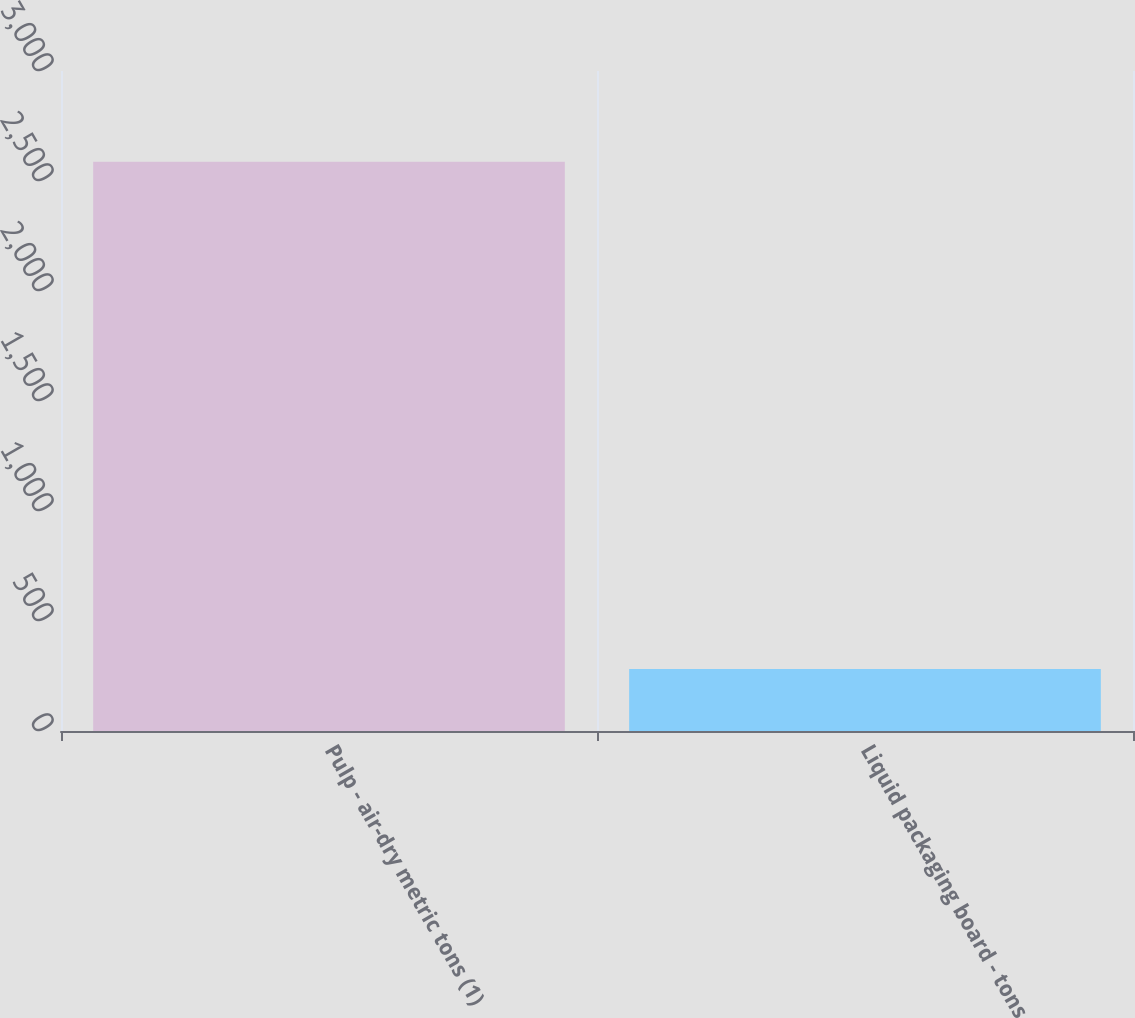Convert chart. <chart><loc_0><loc_0><loc_500><loc_500><bar_chart><fcel>Pulp - air-dry metric tons (1)<fcel>Liquid packaging board - tons<nl><fcel>2588<fcel>282<nl></chart> 